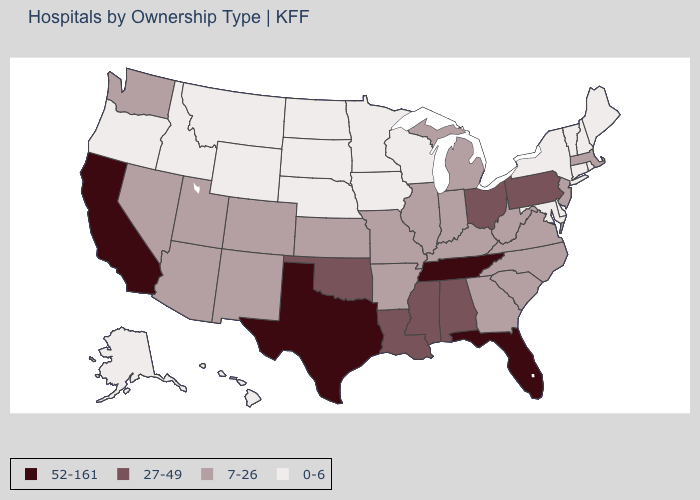Name the states that have a value in the range 27-49?
Keep it brief. Alabama, Louisiana, Mississippi, Ohio, Oklahoma, Pennsylvania. Which states have the lowest value in the USA?
Be succinct. Alaska, Connecticut, Delaware, Hawaii, Idaho, Iowa, Maine, Maryland, Minnesota, Montana, Nebraska, New Hampshire, New York, North Dakota, Oregon, Rhode Island, South Dakota, Vermont, Wisconsin, Wyoming. What is the value of Arizona?
Answer briefly. 7-26. What is the value of Vermont?
Give a very brief answer. 0-6. Does Nevada have the highest value in the West?
Short answer required. No. What is the value of Iowa?
Concise answer only. 0-6. Does the map have missing data?
Quick response, please. No. What is the highest value in the USA?
Be succinct. 52-161. What is the lowest value in the USA?
Give a very brief answer. 0-6. Which states hav the highest value in the Northeast?
Concise answer only. Pennsylvania. Name the states that have a value in the range 0-6?
Answer briefly. Alaska, Connecticut, Delaware, Hawaii, Idaho, Iowa, Maine, Maryland, Minnesota, Montana, Nebraska, New Hampshire, New York, North Dakota, Oregon, Rhode Island, South Dakota, Vermont, Wisconsin, Wyoming. How many symbols are there in the legend?
Write a very short answer. 4. What is the lowest value in the West?
Be succinct. 0-6. 